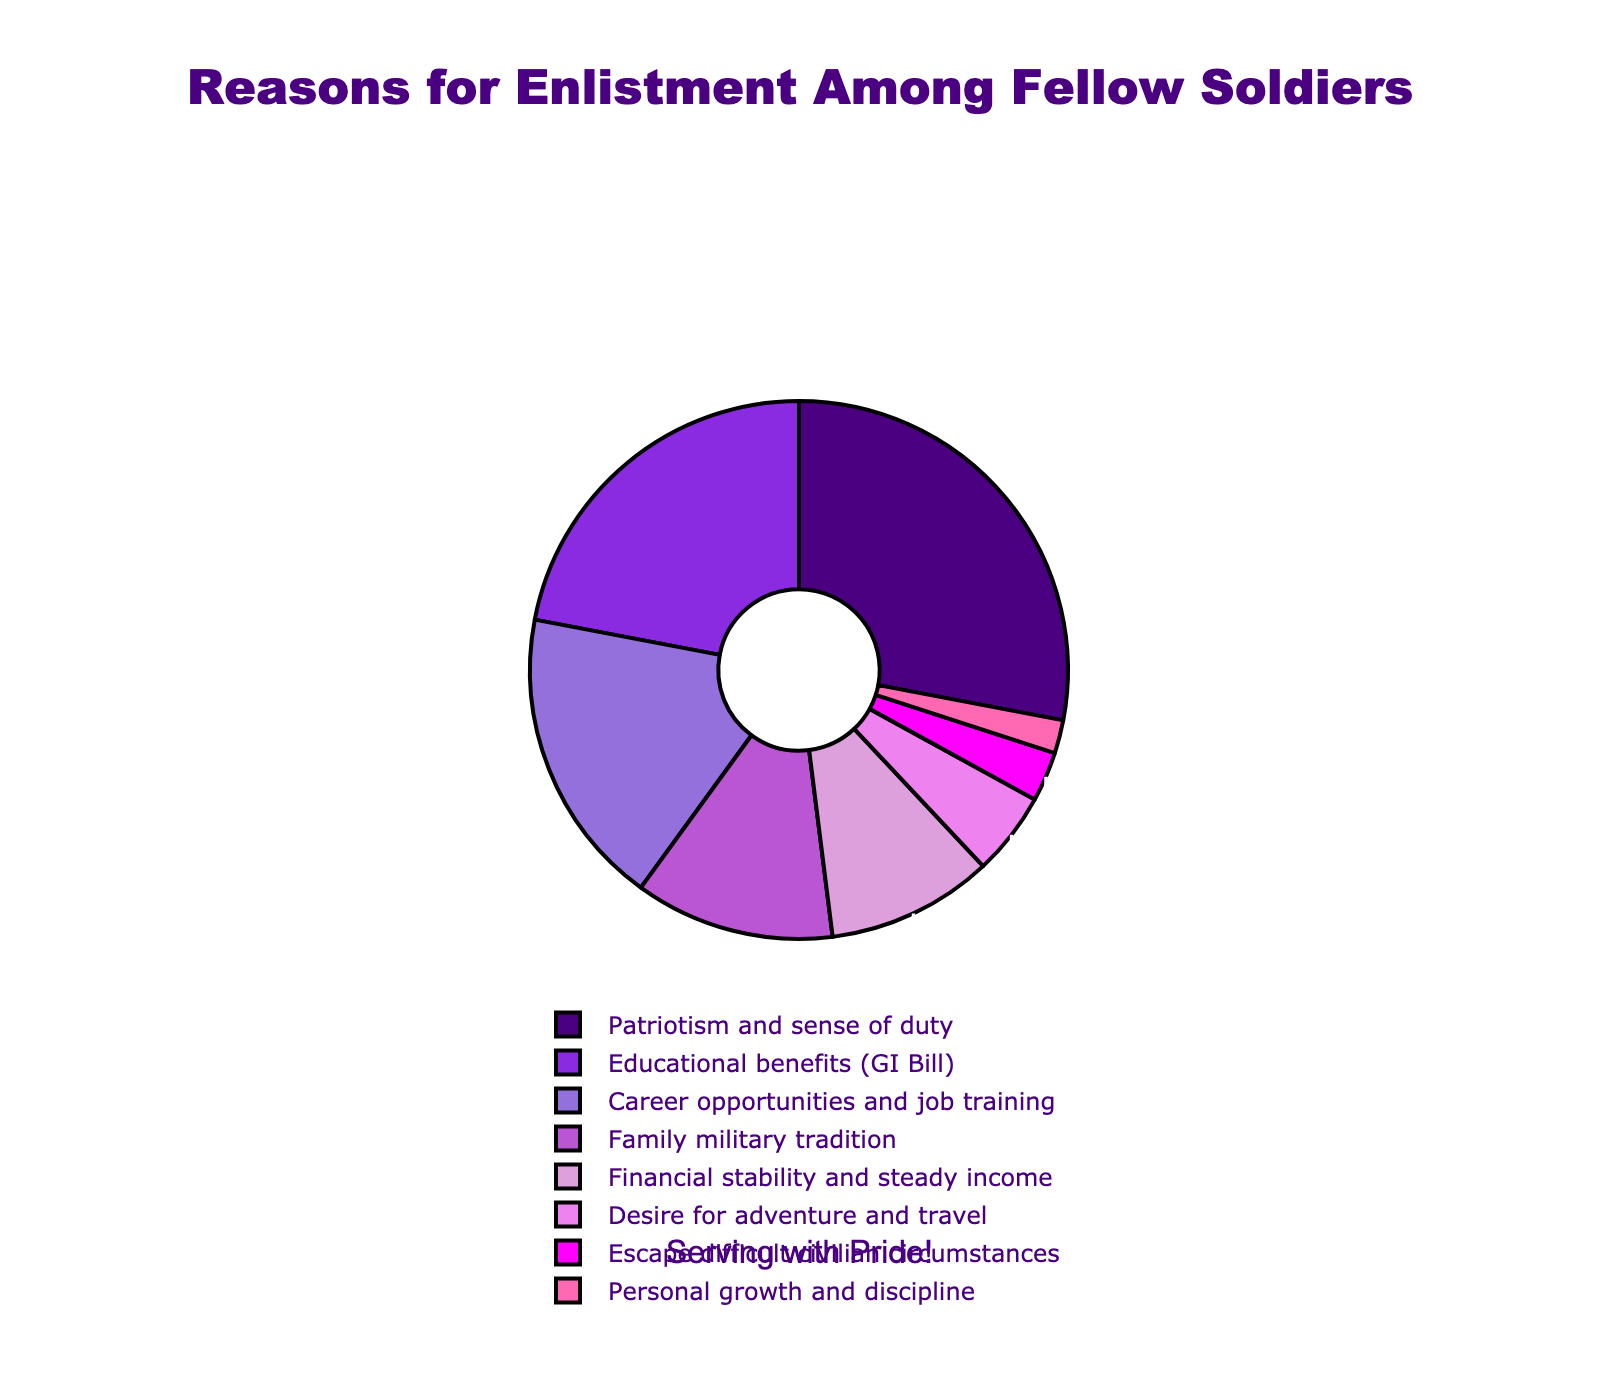Which reason has the highest percentage of enlistment among soldiers? The pie chart shows different reasons for enlistment among soldiers with their corresponding percentages. The reason with the highest percentage, which is the largest segment, is "Patriotism and sense of duty" at 28%.
Answer: Patriotism and sense of duty Which two reasons combined contribute to more than 40% of enlistment motivations? By examining the segments and percentages in the pie chart, we see "Patriotism and sense of duty" (28%) and "Educational benefits (GI Bill)" (22%). Adding these together, 28% + 22% = 50%, which is more than 40%.
Answer: Patriotism and sense of duty, Educational benefits (GI Bill) Which color represents the segment with the highest enlistment reason? The segment for "Patriotism and sense of duty" has the highest percentage (28%) and is visually represented by the color purple (which corresponds to '#4B0082').
Answer: Purple How much larger is the percentage for "Career opportunities and job training" compared to "Personal growth and discipline"? "Career opportunities and job training" accounts for 18%, while "Personal growth and discipline" accounts for 2%. The difference is 18% - 2% = 16%.
Answer: 16% What percentage of soldiers enlisted due to reasons related to financial incentives, combining "Educational benefits (GI Bill)" and "Financial stability and steady income"? Summing the percentages for "Educational benefits (GI Bill)" (22%) and "Financial stability and steady income" (10%), we get 22% + 10% = 32%.
Answer: 32% Which reason for enlistment contributes the least to the overall percentage? The pie chart indicates that "Personal growth and discipline" has the smallest segment, representing only 2%.
Answer: Personal growth and discipline What is the sum of percentages for "Desire for adventure and travel" and "Escape difficult civilian circumstances"? The pie chart shows "Desire for adventure and travel" at 5% and "Escape difficult civilian circumstances" at 3%. Adding these, we get 5% + 3% = 8%.
Answer: 8% Is the percentage of soldiers enlisting due to "Family military tradition" greater than those enlisting for "Financial stability and steady income"? The pie chart indicates "Family military tradition" is 12% and "Financial stability and steady income" is 10%. Since 12% > 10%, the answer is yes.
Answer: Yes How do the combined reasons of "Career opportunities and job training" and "Desire for adventure and travel" compare to the total percentage of soldiers enlisting due to "Patriotism and sense of duty"? The combined percentage of "Career opportunities and job training" (18%) and "Desire for adventure and travel" (5%) is 18% + 5% = 23%. Compared to "Patriotism and sense of duty" at 28%, 23% is less.
Answer: Less 